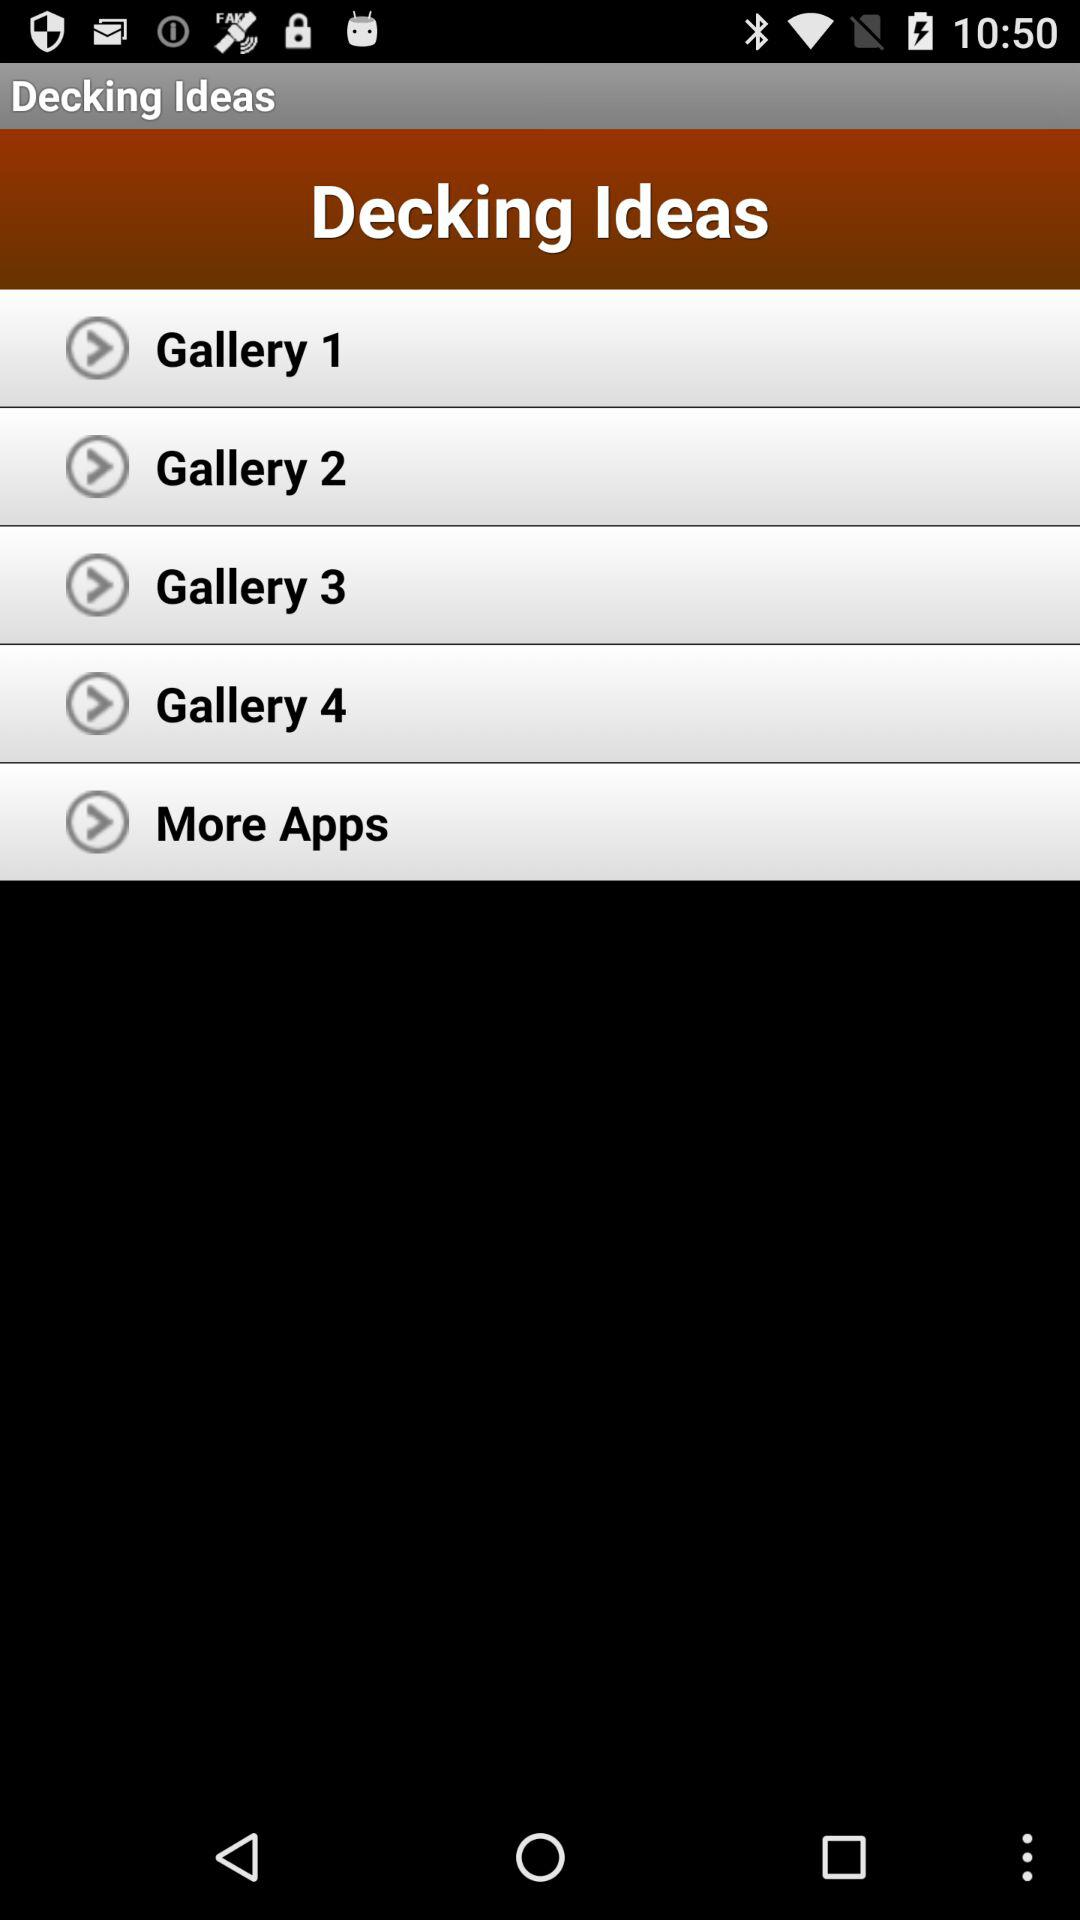What is the application name? The application name is "Decking Ideas". 